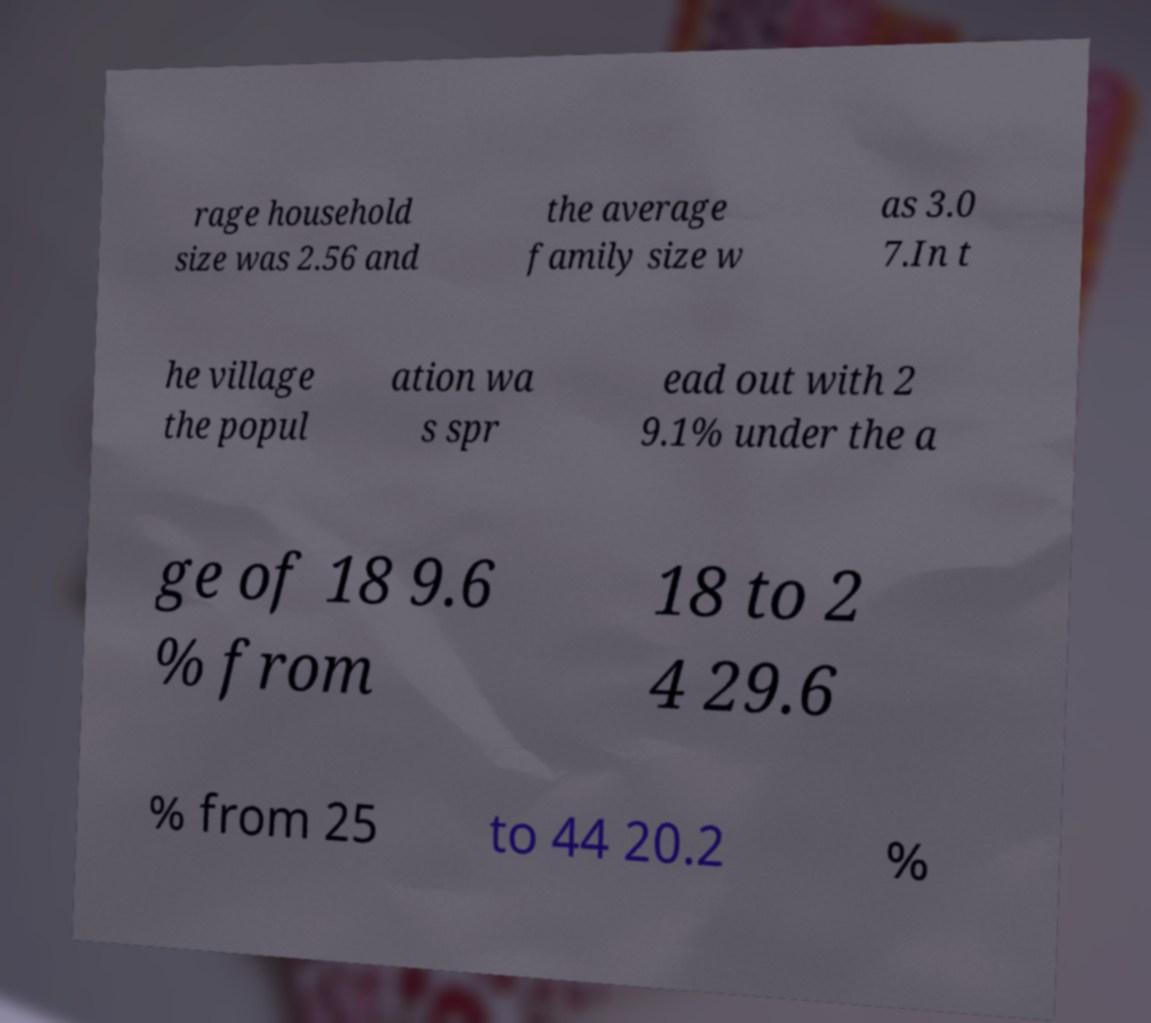Please identify and transcribe the text found in this image. rage household size was 2.56 and the average family size w as 3.0 7.In t he village the popul ation wa s spr ead out with 2 9.1% under the a ge of 18 9.6 % from 18 to 2 4 29.6 % from 25 to 44 20.2 % 